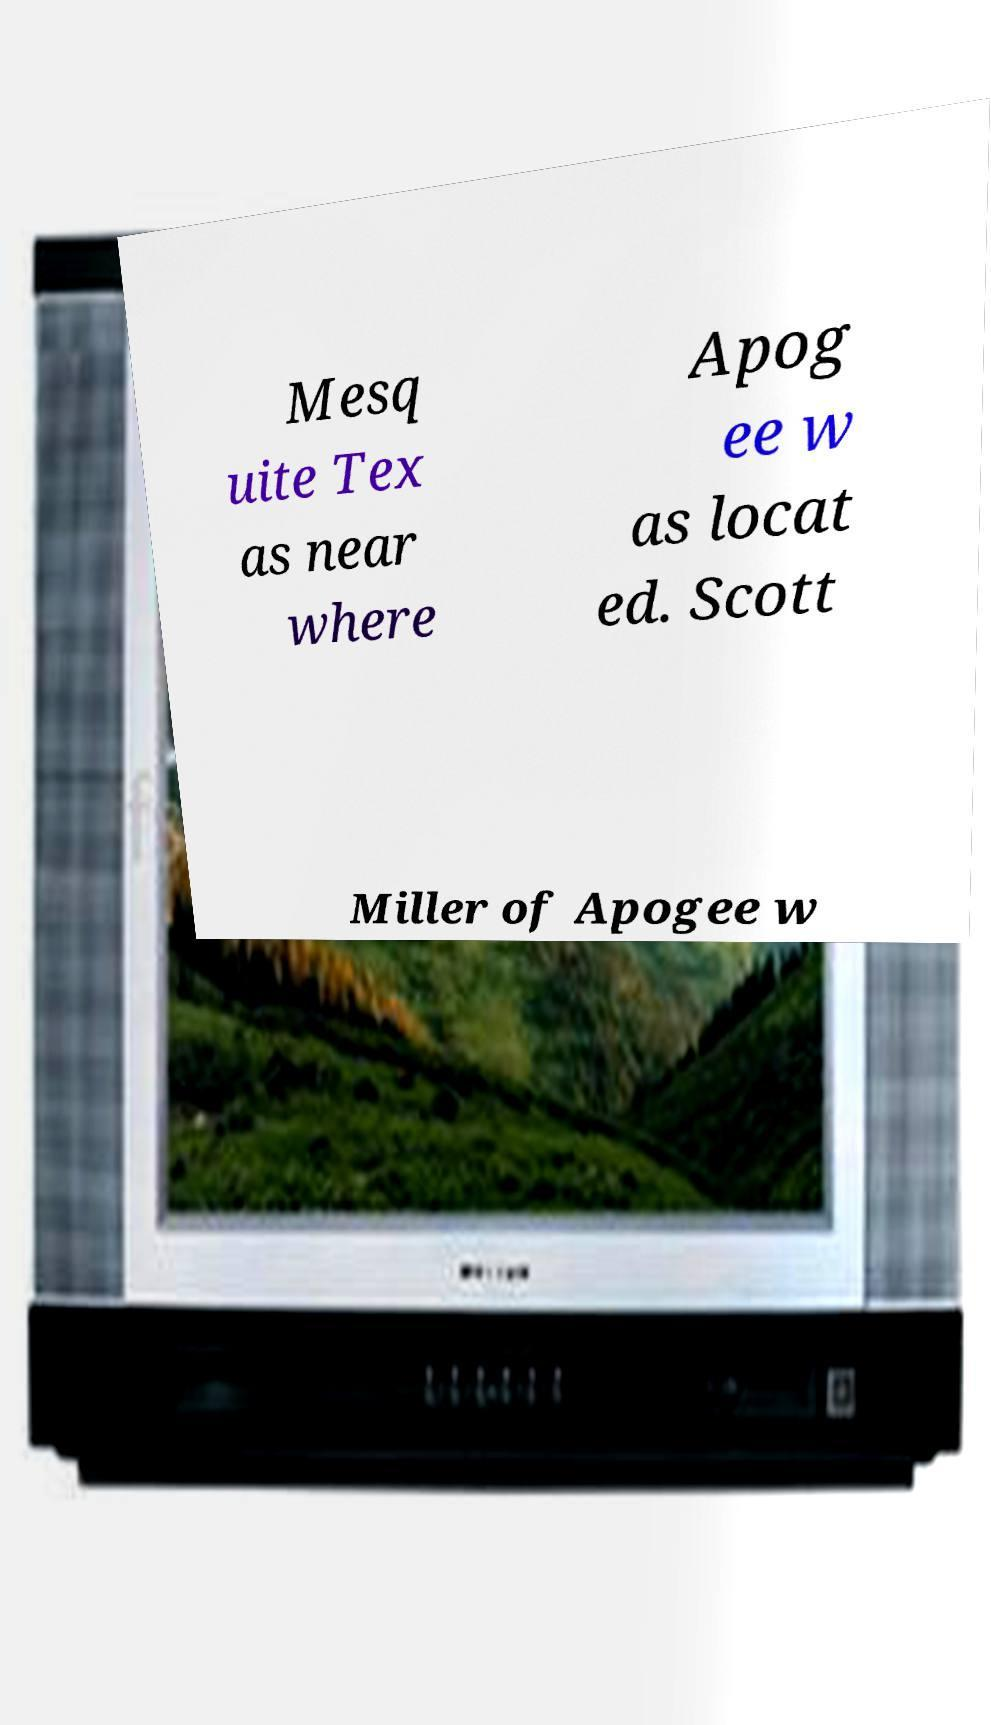Can you accurately transcribe the text from the provided image for me? Mesq uite Tex as near where Apog ee w as locat ed. Scott Miller of Apogee w 